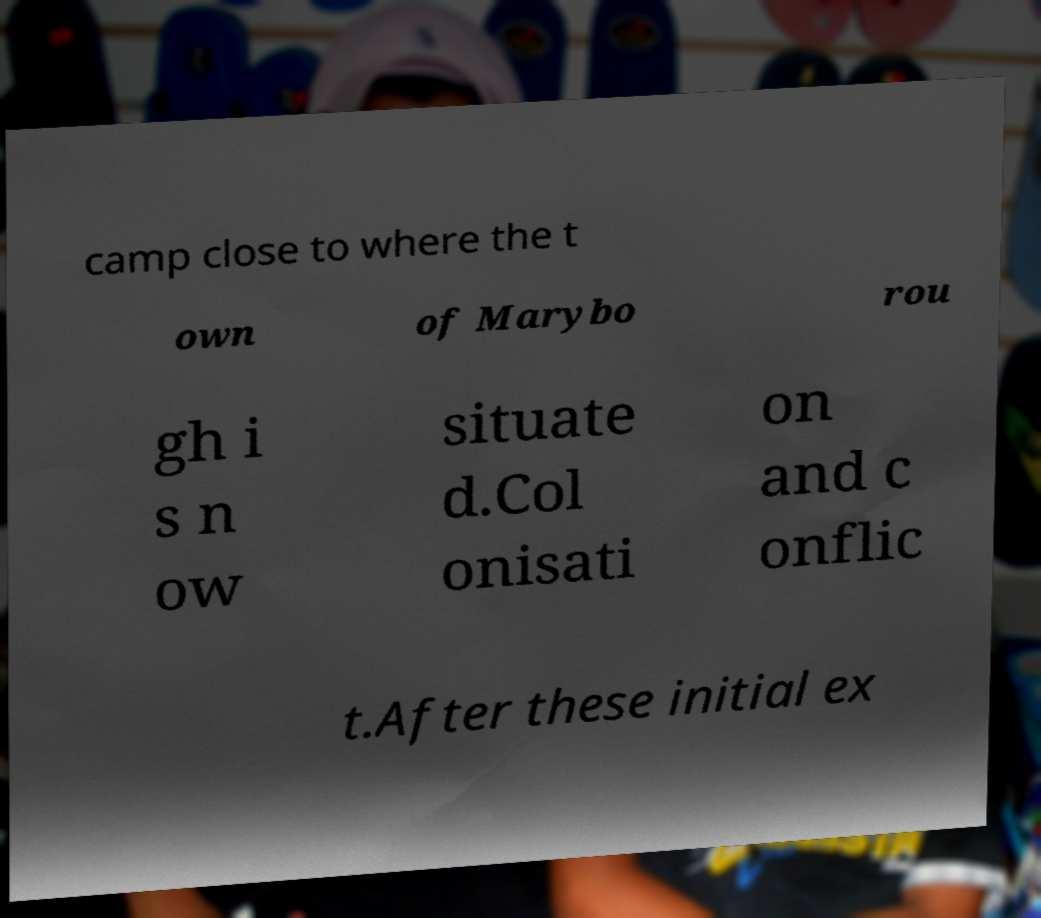Can you read and provide the text displayed in the image?This photo seems to have some interesting text. Can you extract and type it out for me? camp close to where the t own of Marybo rou gh i s n ow situate d.Col onisati on and c onflic t.After these initial ex 